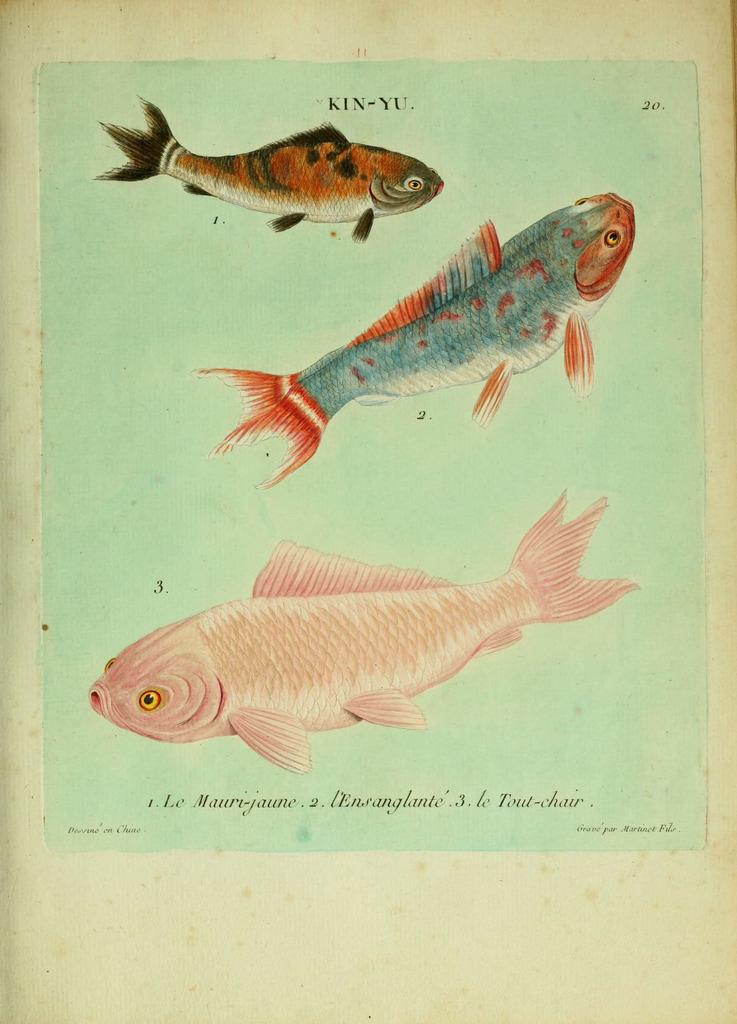What is depicted in the foreground of the poster? There are diagrams of fishes in the foreground of the poster. What can be seen at the top of the poster? There is text at the top of the poster. What is located at the bottom of the poster? There is text at the bottom of the poster. How many cacti are present in the poster? There are no cacti depicted in the poster; it features diagrams of fishes and text. What type of fiction is being promoted in the poster? The poster does not promote any fiction; it contains diagrams of fishes and text. 